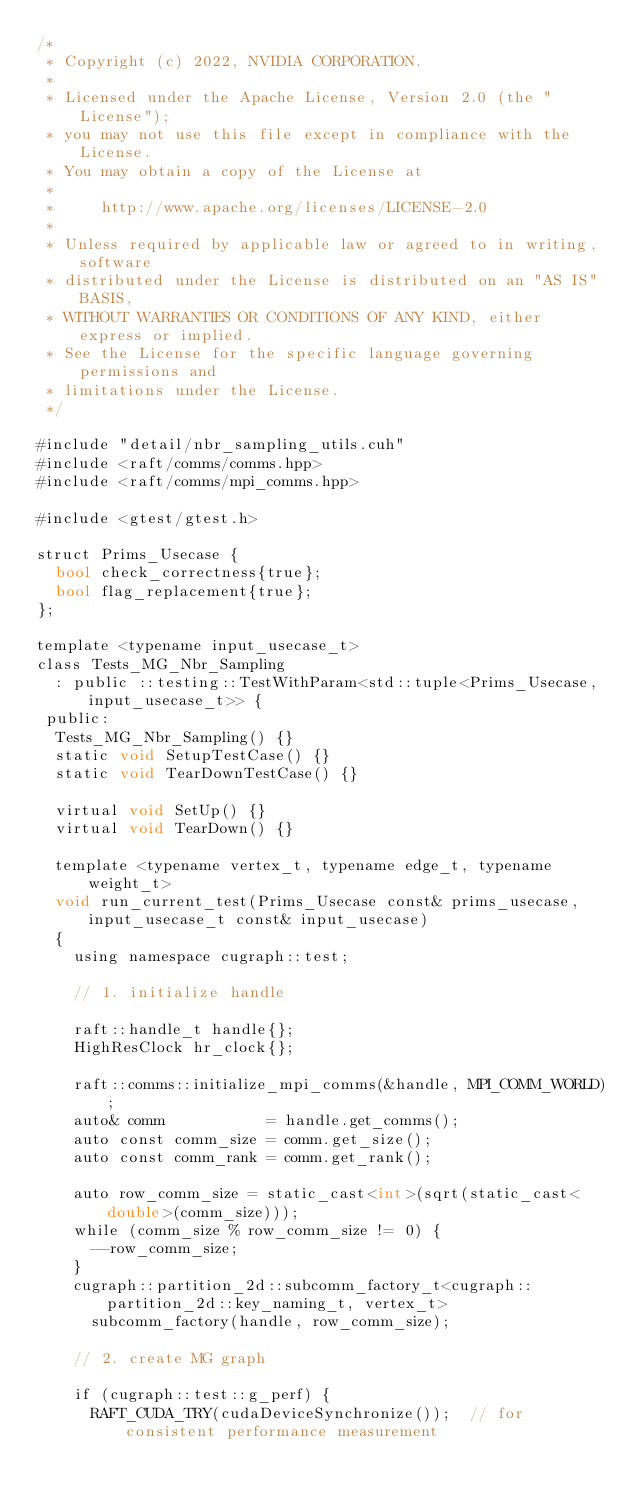Convert code to text. <code><loc_0><loc_0><loc_500><loc_500><_Cuda_>/*
 * Copyright (c) 2022, NVIDIA CORPORATION.
 *
 * Licensed under the Apache License, Version 2.0 (the "License");
 * you may not use this file except in compliance with the License.
 * You may obtain a copy of the License at
 *
 *     http://www.apache.org/licenses/LICENSE-2.0
 *
 * Unless required by applicable law or agreed to in writing, software
 * distributed under the License is distributed on an "AS IS" BASIS,
 * WITHOUT WARRANTIES OR CONDITIONS OF ANY KIND, either express or implied.
 * See the License for the specific language governing permissions and
 * limitations under the License.
 */

#include "detail/nbr_sampling_utils.cuh"
#include <raft/comms/comms.hpp>
#include <raft/comms/mpi_comms.hpp>

#include <gtest/gtest.h>

struct Prims_Usecase {
  bool check_correctness{true};
  bool flag_replacement{true};
};

template <typename input_usecase_t>
class Tests_MG_Nbr_Sampling
  : public ::testing::TestWithParam<std::tuple<Prims_Usecase, input_usecase_t>> {
 public:
  Tests_MG_Nbr_Sampling() {}
  static void SetupTestCase() {}
  static void TearDownTestCase() {}

  virtual void SetUp() {}
  virtual void TearDown() {}

  template <typename vertex_t, typename edge_t, typename weight_t>
  void run_current_test(Prims_Usecase const& prims_usecase, input_usecase_t const& input_usecase)
  {
    using namespace cugraph::test;

    // 1. initialize handle

    raft::handle_t handle{};
    HighResClock hr_clock{};

    raft::comms::initialize_mpi_comms(&handle, MPI_COMM_WORLD);
    auto& comm           = handle.get_comms();
    auto const comm_size = comm.get_size();
    auto const comm_rank = comm.get_rank();

    auto row_comm_size = static_cast<int>(sqrt(static_cast<double>(comm_size)));
    while (comm_size % row_comm_size != 0) {
      --row_comm_size;
    }
    cugraph::partition_2d::subcomm_factory_t<cugraph::partition_2d::key_naming_t, vertex_t>
      subcomm_factory(handle, row_comm_size);

    // 2. create MG graph

    if (cugraph::test::g_perf) {
      RAFT_CUDA_TRY(cudaDeviceSynchronize());  // for consistent performance measurement</code> 